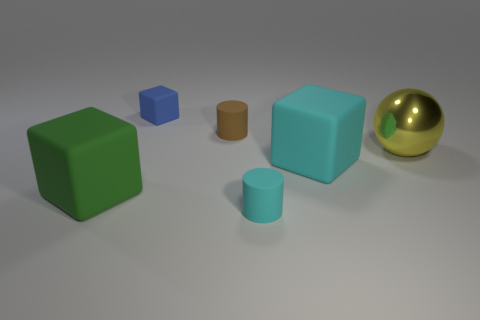What number of other objects are the same shape as the yellow object?
Ensure brevity in your answer.  0. What number of cyan objects are either big rubber cubes or spheres?
Your response must be concise. 1. Does the small blue rubber thing have the same shape as the brown rubber thing?
Make the answer very short. No. There is a big thing that is on the left side of the tiny blue rubber block; are there any large metal spheres on the right side of it?
Offer a very short reply. Yes. Is the number of cyan cylinders that are behind the cyan cylinder the same as the number of metal cylinders?
Make the answer very short. Yes. What number of other objects are there of the same size as the blue matte object?
Your answer should be compact. 2. Are the big object left of the small brown matte cylinder and the cylinder that is behind the small cyan object made of the same material?
Your answer should be very brief. Yes. What size is the cyan matte cylinder in front of the tiny rubber cylinder behind the ball?
Offer a very short reply. Small. Is there a big matte block of the same color as the metallic thing?
Give a very brief answer. No. There is a tiny cylinder behind the large cyan cube; is it the same color as the cube that is behind the large yellow ball?
Keep it short and to the point. No. 